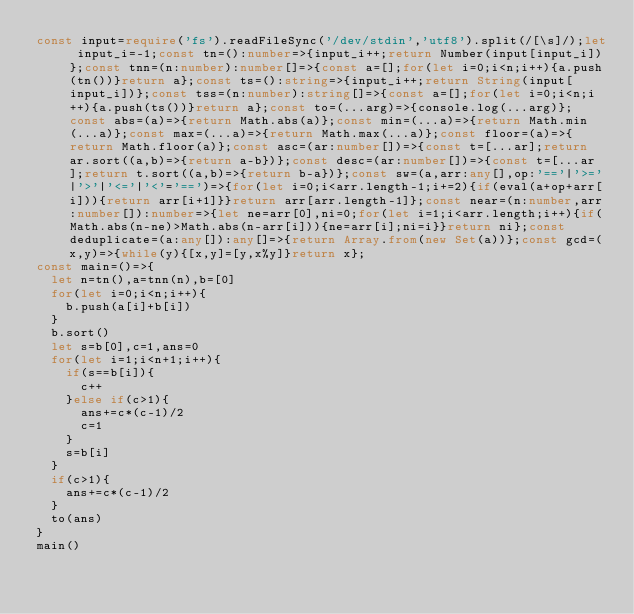<code> <loc_0><loc_0><loc_500><loc_500><_TypeScript_>const input=require('fs').readFileSync('/dev/stdin','utf8').split(/[\s]/);let input_i=-1;const tn=():number=>{input_i++;return Number(input[input_i])};const tnn=(n:number):number[]=>{const a=[];for(let i=0;i<n;i++){a.push(tn())}return a};const ts=():string=>{input_i++;return String(input[input_i])};const tss=(n:number):string[]=>{const a=[];for(let i=0;i<n;i++){a.push(ts())}return a};const to=(...arg)=>{console.log(...arg)};const abs=(a)=>{return Math.abs(a)};const min=(...a)=>{return Math.min(...a)};const max=(...a)=>{return Math.max(...a)};const floor=(a)=>{return Math.floor(a)};const asc=(ar:number[])=>{const t=[...ar];return ar.sort((a,b)=>{return a-b})};const desc=(ar:number[])=>{const t=[...ar];return t.sort((a,b)=>{return b-a})};const sw=(a,arr:any[],op:'=='|'>='|'>'|'<='|'<'='==')=>{for(let i=0;i<arr.length-1;i+=2){if(eval(a+op+arr[i])){return arr[i+1]}}return arr[arr.length-1]};const near=(n:number,arr:number[]):number=>{let ne=arr[0],ni=0;for(let i=1;i<arr.length;i++){if(Math.abs(n-ne)>Math.abs(n-arr[i])){ne=arr[i];ni=i}}return ni};const deduplicate=(a:any[]):any[]=>{return Array.from(new Set(a))};const gcd=(x,y)=>{while(y){[x,y]=[y,x%y]}return x};
const main=()=>{
  let n=tn(),a=tnn(n),b=[0]
  for(let i=0;i<n;i++){
    b.push(a[i]+b[i])
  }
  b.sort()
  let s=b[0],c=1,ans=0
  for(let i=1;i<n+1;i++){
    if(s==b[i]){
      c++
    }else if(c>1){
      ans+=c*(c-1)/2
      c=1
    }
    s=b[i]
  }
  if(c>1){
    ans+=c*(c-1)/2
  }
  to(ans)
}
main()
</code> 